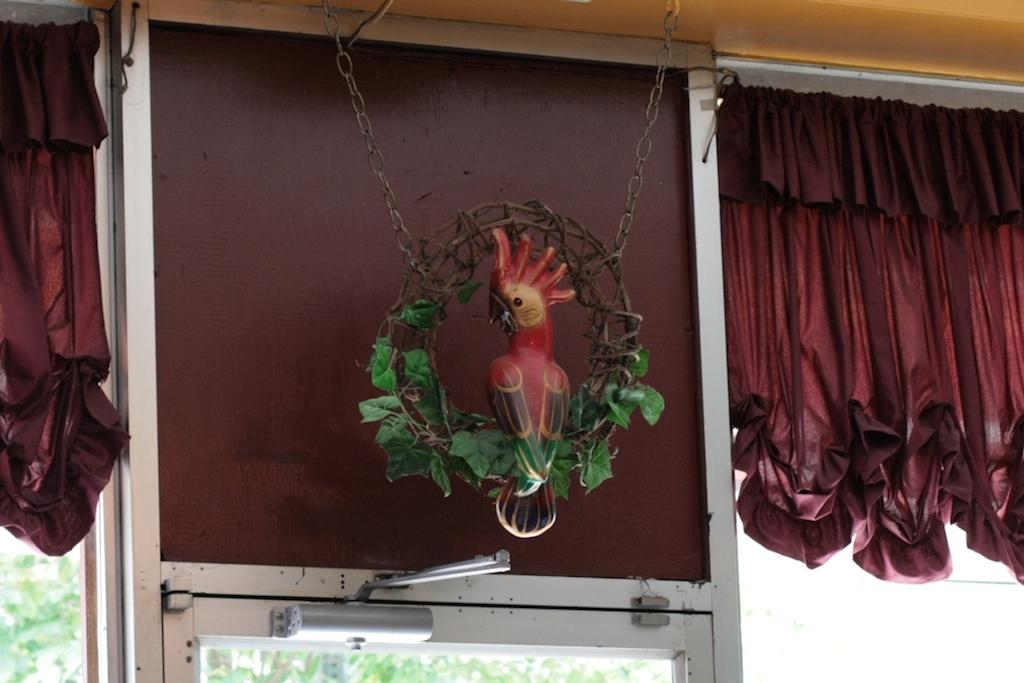What can be seen in the image that provides a view of the outdoors? There is a window in the image that provides a view of the outdoors. What is covering the window in the image? There are two curtains in front of the window. What is hanging down in the middle of the window? There is a parrot toy hanging down in the middle of the window. What can be seen behind the window? There are trees visible behind the window. What type of elbow is visible in the image? There is no elbow present in the image. Can you see any fish swimming behind the window? There are no fish visible in the image; only trees can be seen behind the window. 